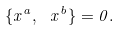<formula> <loc_0><loc_0><loc_500><loc_500>\{ x ^ { a } , \ x ^ { b } \} = 0 .</formula> 